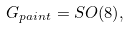<formula> <loc_0><loc_0><loc_500><loc_500>G _ { p a i n t } = S O ( 8 ) ,</formula> 